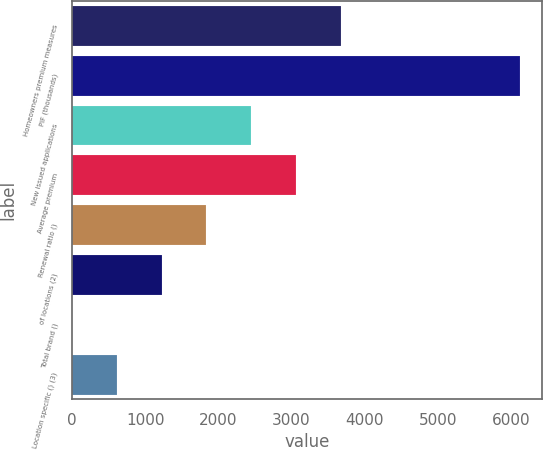Convert chart to OTSL. <chart><loc_0><loc_0><loc_500><loc_500><bar_chart><fcel>Homeowners premium measures<fcel>PIF (thousands)<fcel>New issued applications<fcel>Average premium<fcel>Renewal ratio ()<fcel>of locations (2)<fcel>Total brand ()<fcel>Location specific () (3)<nl><fcel>3672.44<fcel>6120<fcel>2448.66<fcel>3060.55<fcel>1836.77<fcel>1224.88<fcel>1.1<fcel>612.99<nl></chart> 